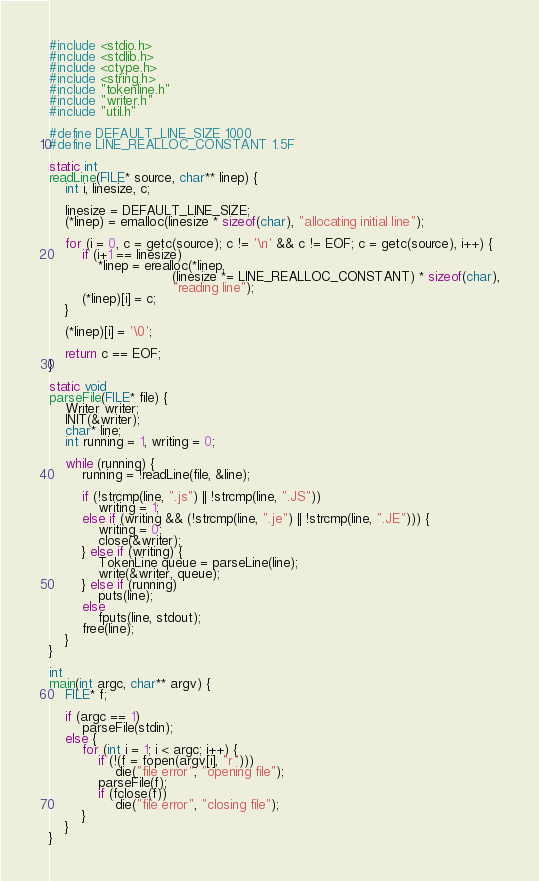Convert code to text. <code><loc_0><loc_0><loc_500><loc_500><_C_>#include <stdio.h>
#include <stdlib.h>
#include <ctype.h>
#include <string.h>
#include "tokenline.h"
#include "writer.h"
#include "util.h"

#define DEFAULT_LINE_SIZE 1000
#define LINE_REALLOC_CONSTANT 1.5F

static int
readLine(FILE* source, char** linep) {
    int i, linesize, c;

    linesize = DEFAULT_LINE_SIZE;
    (*linep) = emalloc(linesize * sizeof(char), "allocating initial line");

    for (i = 0, c = getc(source); c != '\n' && c != EOF; c = getc(source), i++) {
        if (i+1 == linesize)
            *linep = erealloc(*linep,
                              (linesize *= LINE_REALLOC_CONSTANT) * sizeof(char),
                              "reading line");
        (*linep)[i] = c;
    }

    (*linep)[i] = '\0';

    return c == EOF;
}

static void
parseFile(FILE* file) {
    Writer writer;
    INIT(&writer);
    char* line;
    int running = 1, writing = 0;

    while (running) {
        running = !readLine(file, &line);

        if (!strcmp(line, ".js") || !strcmp(line, ".JS"))
            writing = 1;
        else if (writing && (!strcmp(line, ".je") || !strcmp(line, ".JE"))) {
            writing = 0;
            close(&writer);
        } else if (writing) {
            TokenLine queue = parseLine(line);
            write(&writer, queue);
        } else if (running)
            puts(line);
        else
            fputs(line, stdout);
        free(line);
    }
}

int
main(int argc, char** argv) {
    FILE* f;

    if (argc == 1)
        parseFile(stdin);
    else {
        for (int i = 1; i < argc; i++) {
            if (!(f = fopen(argv[i], "r")))
                die("file error", "opening file");
            parseFile(f);
            if (fclose(f))
                die("file error", "closing file");
        }
    }
}
</code> 